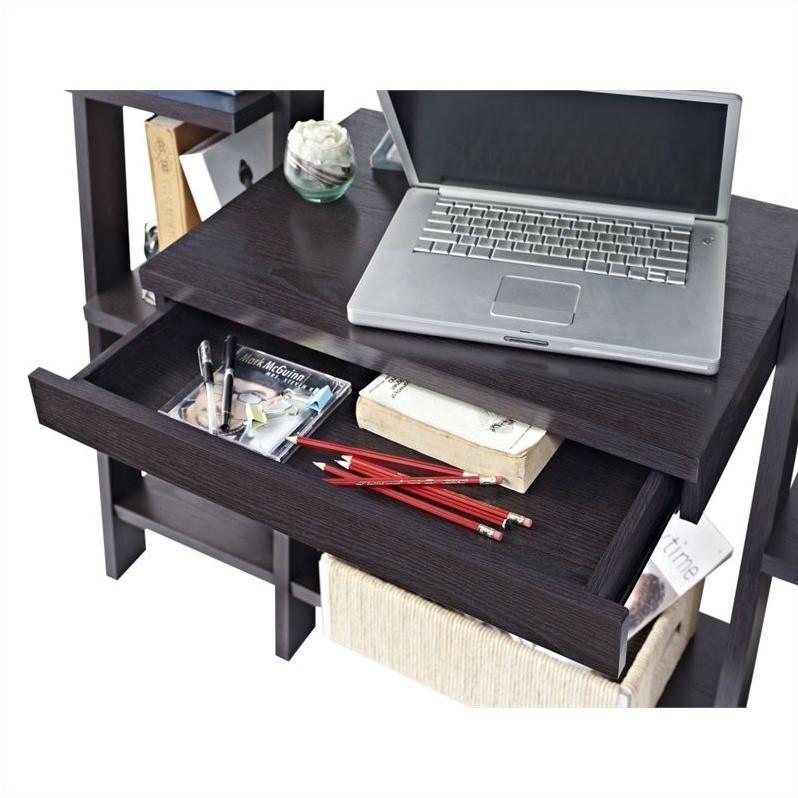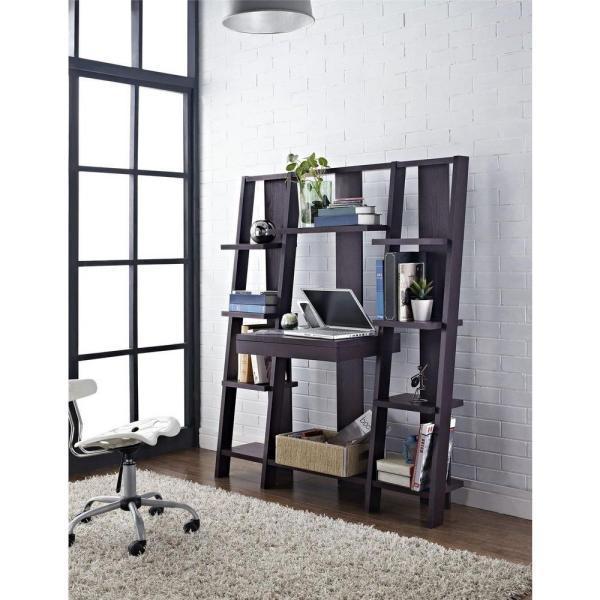The first image is the image on the left, the second image is the image on the right. Evaluate the accuracy of this statement regarding the images: "A silver colored laptop is sitting on a black desk that is connected to an entertainment center.". Is it true? Answer yes or no. Yes. The first image is the image on the left, the second image is the image on the right. Considering the images on both sides, is "Both images contain laptops." valid? Answer yes or no. Yes. 